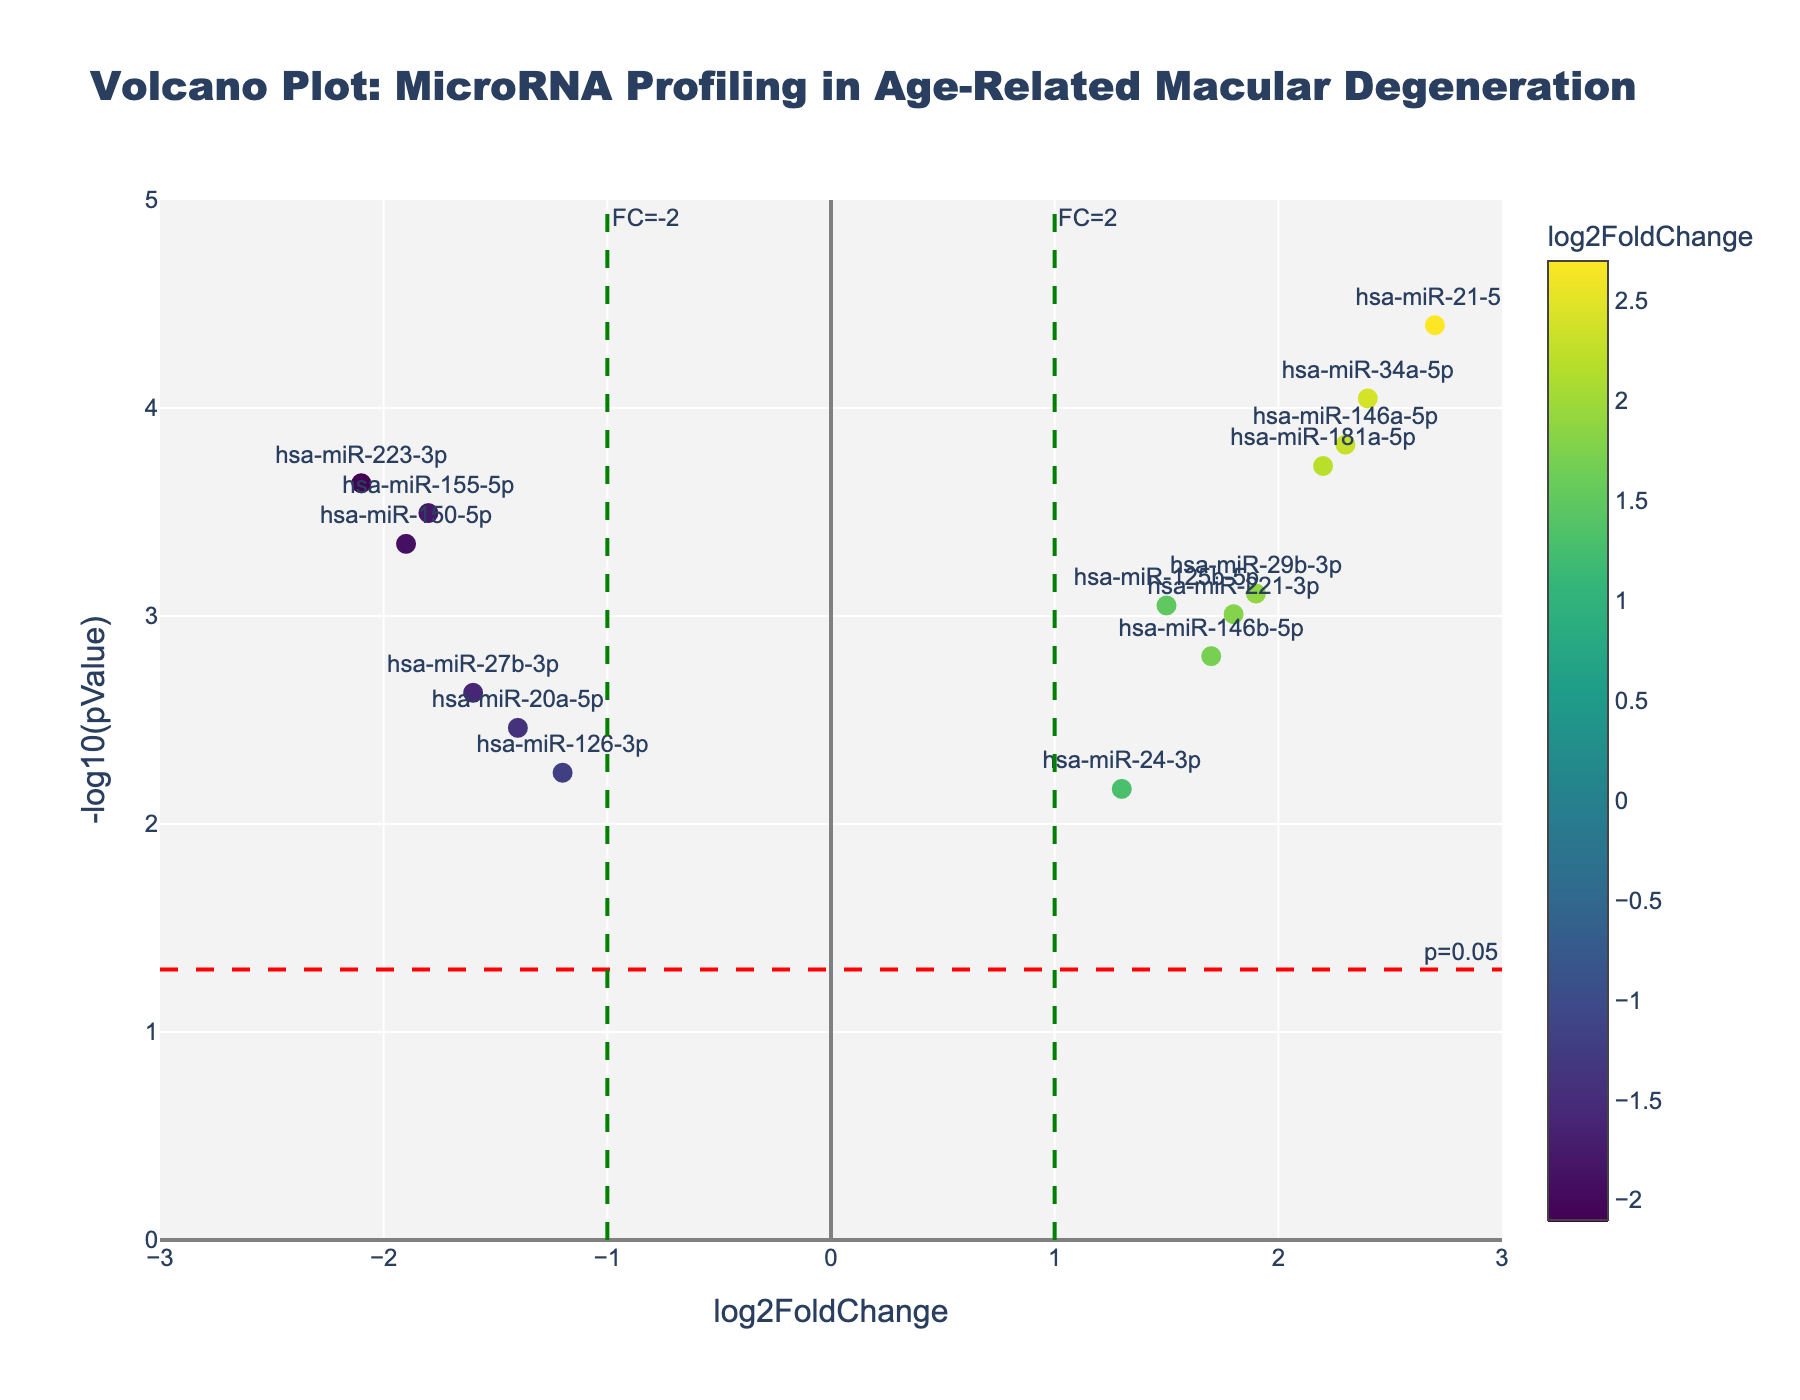what is the title of the plot? The title of the plot is usually found at the top center of the figure in a larger and bold font. Here, it's "Volcano Plot: MicroRNA Profiling in Age-Related Macular Degeneration".
Answer: Volcano Plot: MicroRNA Profiling in Age-Related Macular Degeneration Which miRNA has the highest fold change? To determine the highest fold change, we need to find the highest value on the x-axis labeled log2FoldChange. By inspecting the figure, miRNA with the highest value is "hsa-miR-21-5p".
Answer: hsa-miR-21-5p How many miRNAs have a significant p-value (p < 0.05)? To count miRNAs with significant p-values, we check how many points are above the horizontal line y = -log10(0.05). Each point above the line represents a significant p-value (p < 0.05). There are 13 such miRNAs.
Answer: 13 Which two miRNAs have the most extreme fold changes in opposite directions? We look for one point with the highest positive x-value and another with the highest negative x-value on the log2FoldChange axis. The most extreme positive is "hsa-miR-21-5p" and the most extreme negative is "hsa-miR-223-3p".
Answer: hsa-miR-21-5p and hsa-miR-223-3p What does the color in the scatter plot represent? The color of the points in the scatter plot indicates the log2FoldChange. This is showcased through the color scale on the right-side of the plot.
Answer: log2FoldChange Which miRNA has the most significant p-value? To find the miRNA with the most significant p-value, we look for the point that is highest on the y-axis (-log10(pValue)). The one with greatest height is "hsa-miR-21-5p".
Answer: hsa-miR-21-5p What is the log2FoldChange range covered by the miRNAs? The log2FoldChange range can be calculated from the x-axis, which ranges from approximately -2.1 to 2.7.
Answer: -2.1 to 2.7 Which miRNA is closest to the fold change of -2? To find the closest to fold change of -2, locate the point nearest the vertical line x = -1. It’s "hsa-miR-155-5p".
Answer: hsa-miR-155-5p How do you know which miRNAs have anti-inflammatory properties based on the plot? Anti-inflammatory miRNAs are indicated by negative log2FoldChange values. To identify them, look for miRNAs on the left side of the x = 0 line with significant p-values.
Answer: check left side below x=0 with significant p-values What is the importance of the red dashed line? The red dashed line represents the threshold for statistical significance, y = -log10(0.05). Points above this line are considered statistically significant (p < 0.05).
Answer: p-value significance threshold 